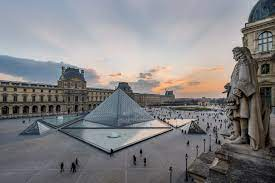This detail is captivating; can you tell me more about the glass pyramid and its significance? Sure! The glass pyramid at the Louvre Museum is an iconic modern architectural addition designed by Chinese-American architect I.M. Pei. Completed in 1989, the pyramid stands at 21.6 meters (71 feet) high and is made from 673 glass segments. The pyramid's modern design sparked controversy upon its unveiling, as it marked a significant departure from the classical aesthetics of the historic Louvre. However, it has since become a beloved symbol of the museum, representing the blending of old and new. The pyramid serves as the main entrance to the museum, with visitors descending into an underground lobby before accessing the vast collections of art and artifacts housed within the Louvre. Why did I.M. Pei choose a glass pyramid for this site? I.M. Pei chose the glass pyramid design for several reasons. The transparency of the glass allows natural light to filter down into the subterranean lobby, creating an inviting and well-lit entrance space. The pyramid shape itself echoes the geometric precision and historic grandeur often associated with ancient civilizations, such as the Egyptians, symbolically linking the Louvre's collection of ancient artifacts with its architecture. Pei also intended the pyramid to represent a bridge between the old and the new, conveying a sense of timelessness and innovation. Its sleek design is in harmony with the modernist aesthetics and contrasts beautifully with the traditional classical façades of the Louvre buildings, thus creating a visually dynamic and thought-provoking juxtaposition. Do you think the pyramid adds to the aesthetic appeal of the museum's courtyard? Yes, the pyramid certainly adds a unique aesthetic dimension to the Louvre's courtyard. Its modern design contrasts with the classical architecture of the surrounding buildings, creating a striking visual interplay between past and present. The pyramid's reflective surfaces and the reflective pool of water enhance this effect, offering varying impressions depending on the light and weather conditions. The glass structure also provides a sense of openness and transparency, inviting visitors to explore the museum's treasures. Overall, the pyramid adds an element of contemporary elegance and serves as a focal point that draws the eye and enriches the overall experience of the courtyard. 